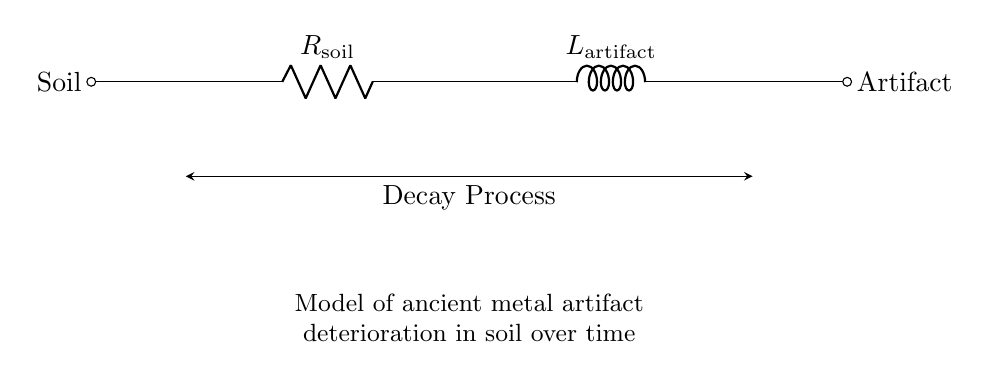What components are present in this circuit? The circuit includes a resistor labeled R_sub_soil and an inductor labeled L_sub_artifact, as seen in the diagram.
Answer: resistor and inductor What does the resistor represent in this circuit? The resistor R_sub_soil represents the resistance caused by the soil in which the artifact is located, affecting the decay process of the artifact.
Answer: soil resistance What does the inductor represent in this circuit? The inductor L_sub_artifact represents the inductive properties related to the artifact itself, indicating how it responds to changing conditions in the soil over time.
Answer: artifact inductance What does the arrow indicating the decay process suggest? The arrow indicating the decay process points to the interaction between the resistor and the inductor, suggesting a dynamic relationship affecting the decay of the artifact.
Answer: dynamic relationship How does the RL circuit model the deterioration process? The RL circuit models the deterioration process by showing how the resistance of the soil and the inductance of the artifact interact, influencing the rate and manner of decay over time.
Answer: interaction influences decay What is the significance of the 'Artifact' label in the circuit? The 'Artifact' label signifies the focus of the RL circuit, representing the ancient metal object being analyzed for its decay characteristics in the soil environment.
Answer: analysis focus What does the 'Soil' label indicate in the circuit? The 'Soil' label indicates the external environment around the artifact, which plays a crucial role in its decay through resistance represented by the resistor.
Answer: external environment 